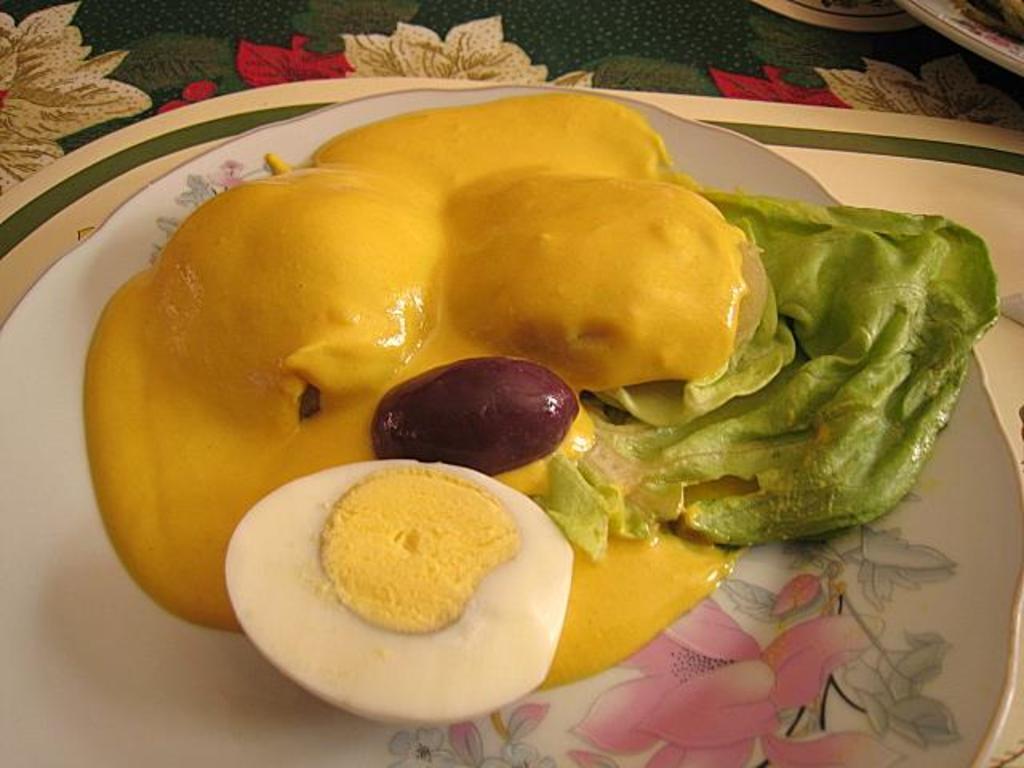Could you give a brief overview of what you see in this image? In this image we can see a plate on a mat. There is a food item in the plate. Also there is an egg in the plate. 